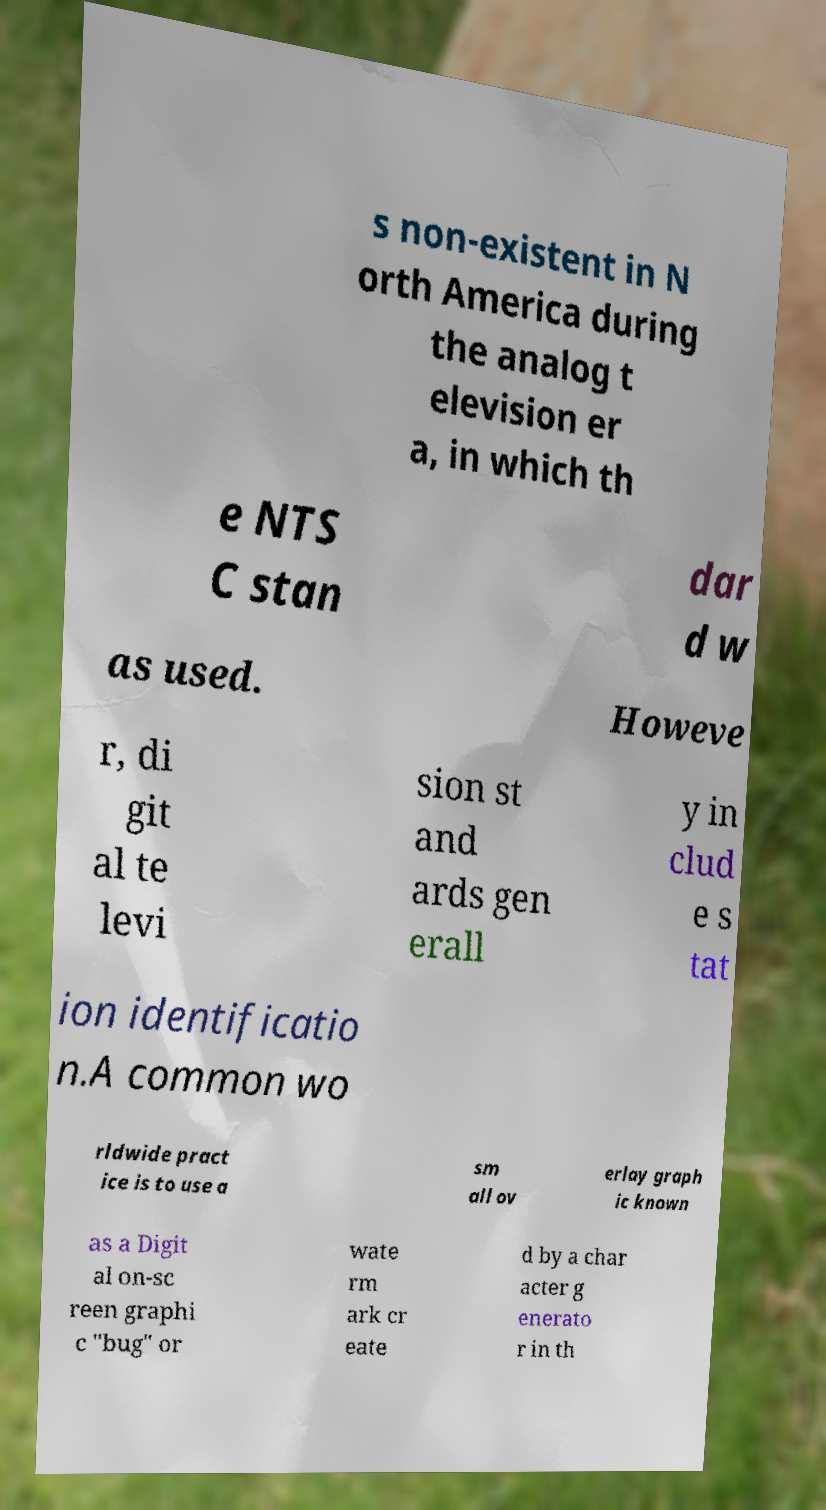Can you accurately transcribe the text from the provided image for me? s non-existent in N orth America during the analog t elevision er a, in which th e NTS C stan dar d w as used. Howeve r, di git al te levi sion st and ards gen erall y in clud e s tat ion identificatio n.A common wo rldwide pract ice is to use a sm all ov erlay graph ic known as a Digit al on-sc reen graphi c "bug" or wate rm ark cr eate d by a char acter g enerato r in th 